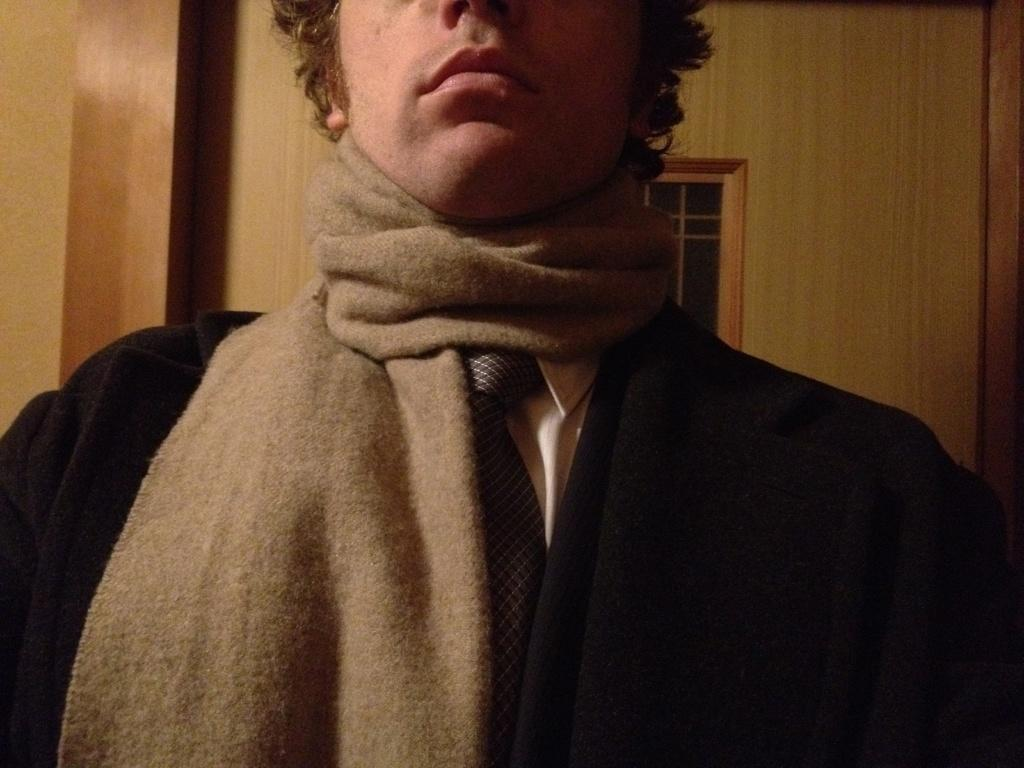What is the main subject of the image? There is a man standing in the image. What is the man wearing in the image? The man is wearing a black color blazer and a tie. What can be seen in the background of the image? There is a wooden wall and a window in the background of the image. How many partners does the man have in the image? There is no indication of a partner in the image; it only features a man standing. What division is the man working in, as seen in the image? There is no information about the man's division or job in the image; it only shows his attire and the background. 